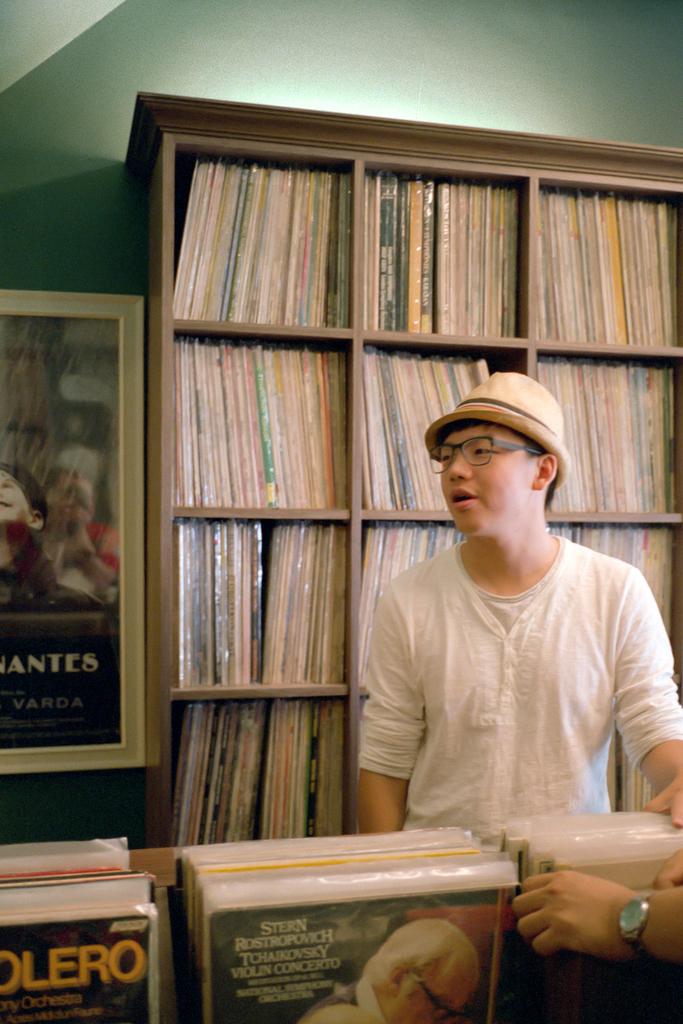What is the album up front?
Keep it short and to the point. Stern rostropovich tchaikovsky violin concerto. 